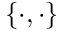<formula> <loc_0><loc_0><loc_500><loc_500>\{ \cdot , \cdot \}</formula> 